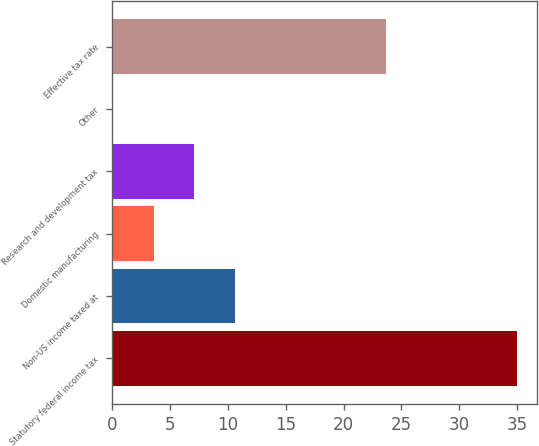Convert chart to OTSL. <chart><loc_0><loc_0><loc_500><loc_500><bar_chart><fcel>Statutory federal income tax<fcel>Non-US income taxed at<fcel>Domestic manufacturing<fcel>Research and development tax<fcel>Other<fcel>Effective tax rate<nl><fcel>35<fcel>10.57<fcel>3.59<fcel>7.08<fcel>0.1<fcel>23.7<nl></chart> 